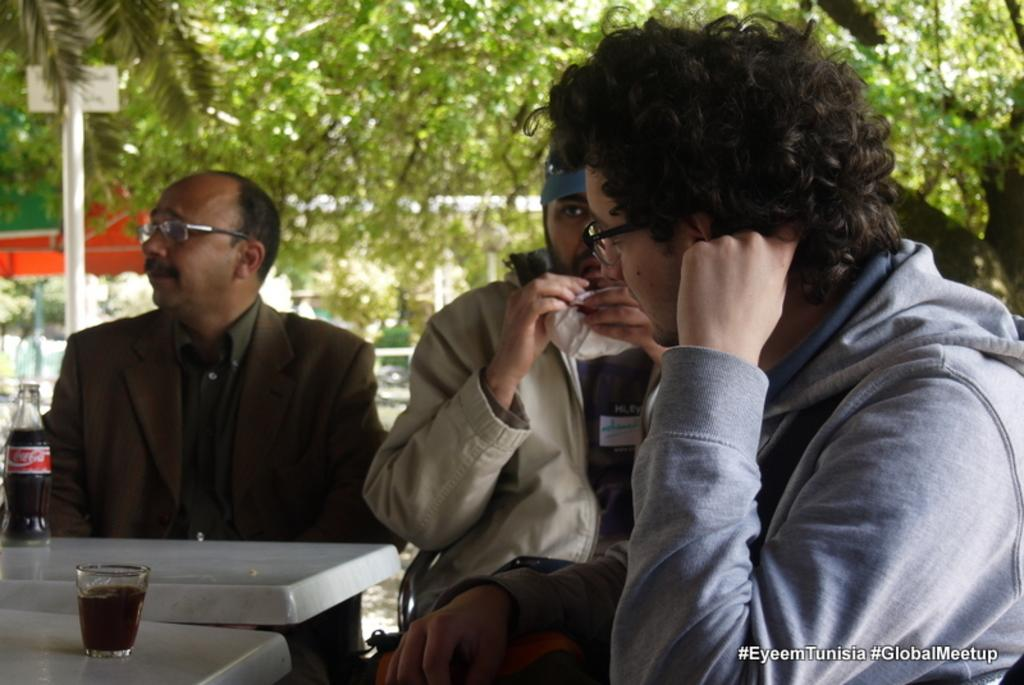How many people are in the image? There is a group of people in the image. What are the people doing in the image? The people are sitting on chairs. What can be seen on the chairs? There are items placed on the chairs. Are the people eating anything in the image? Yes, some people are eating. What can be seen in the background of the image? There are trees, a board, a pole, and stalls in the background. Can you see a rat running across the board in the background? There is no rat present in the image. What type of soap is being used by the people in the image? There is no soap visible in the image, and the people are not using any soap. 